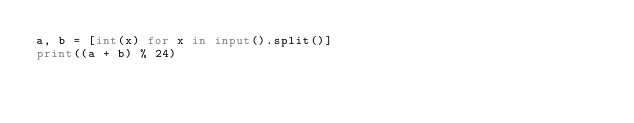Convert code to text. <code><loc_0><loc_0><loc_500><loc_500><_Python_>a, b = [int(x) for x in input().split()]
print((a + b) % 24)
</code> 